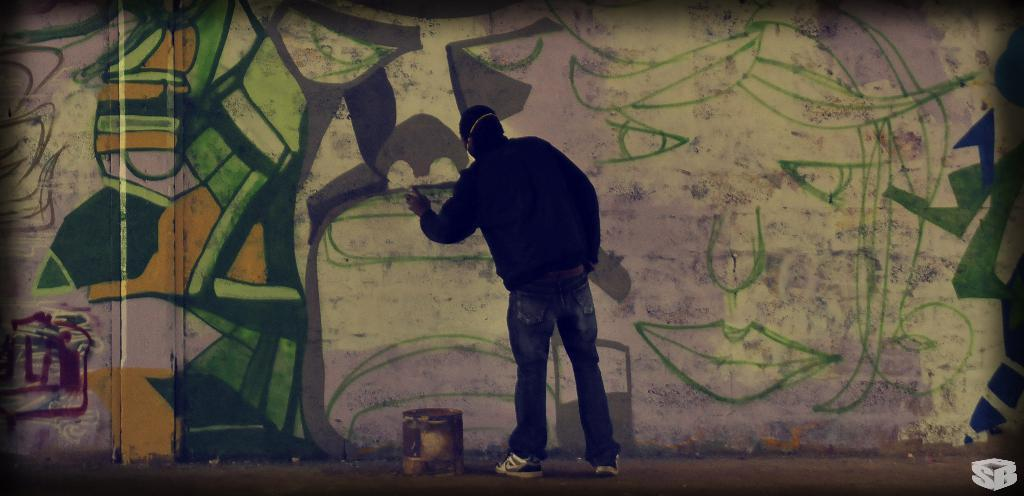Who is the person in the image? There is a man in the image. What is the man doing in the image? The man is painting on a wall. What is the man wearing in the image? The man is wearing a black color jacket and jeans. What object is in front of the man in the image? There is a bucket in front of the man. What type of question is the man asking in the image? There is no indication in the image that the man is asking a question. 